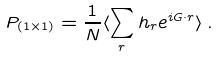<formula> <loc_0><loc_0><loc_500><loc_500>P _ { ( 1 \times 1 ) } = \frac { 1 } { N } \langle \sum _ { r } h _ { r } e ^ { i { G } \cdot { r } } \rangle \, .</formula> 